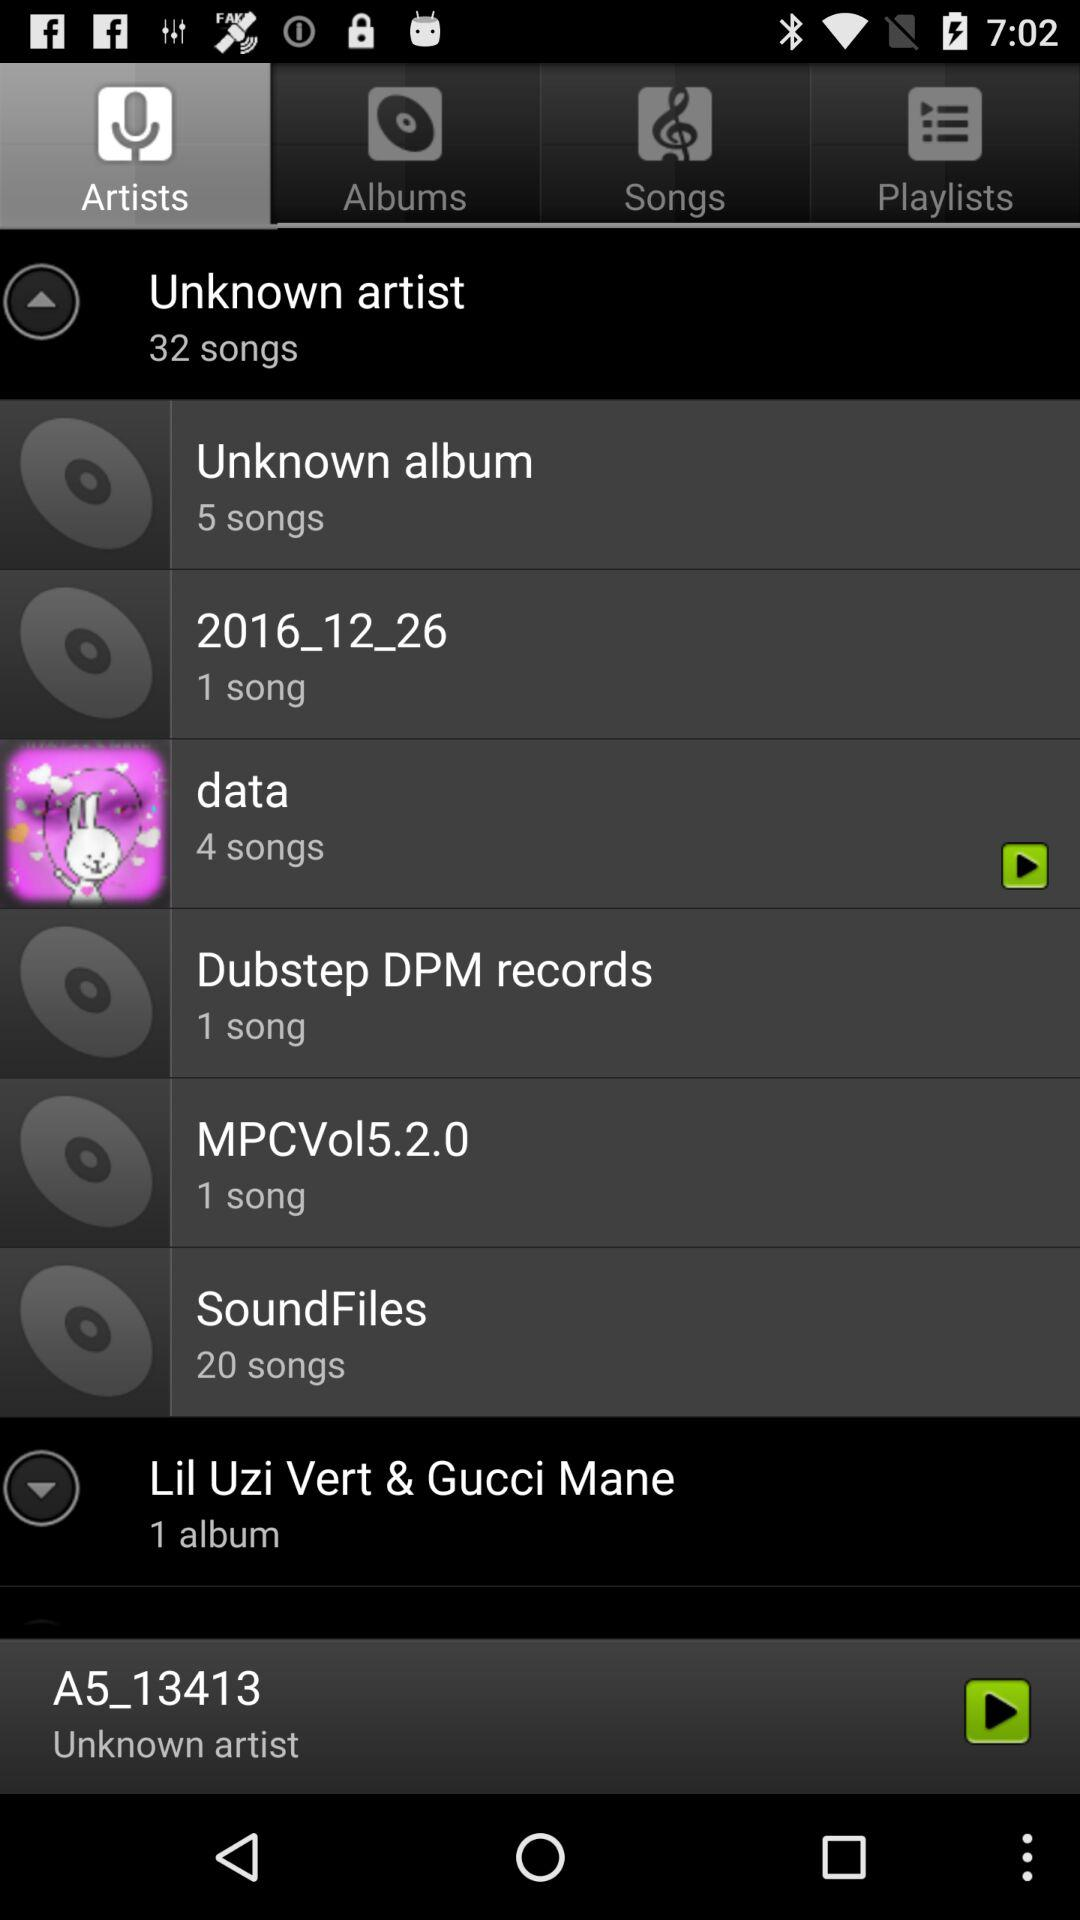Which tab is currently selected? The currently selected tab is "Artists". 